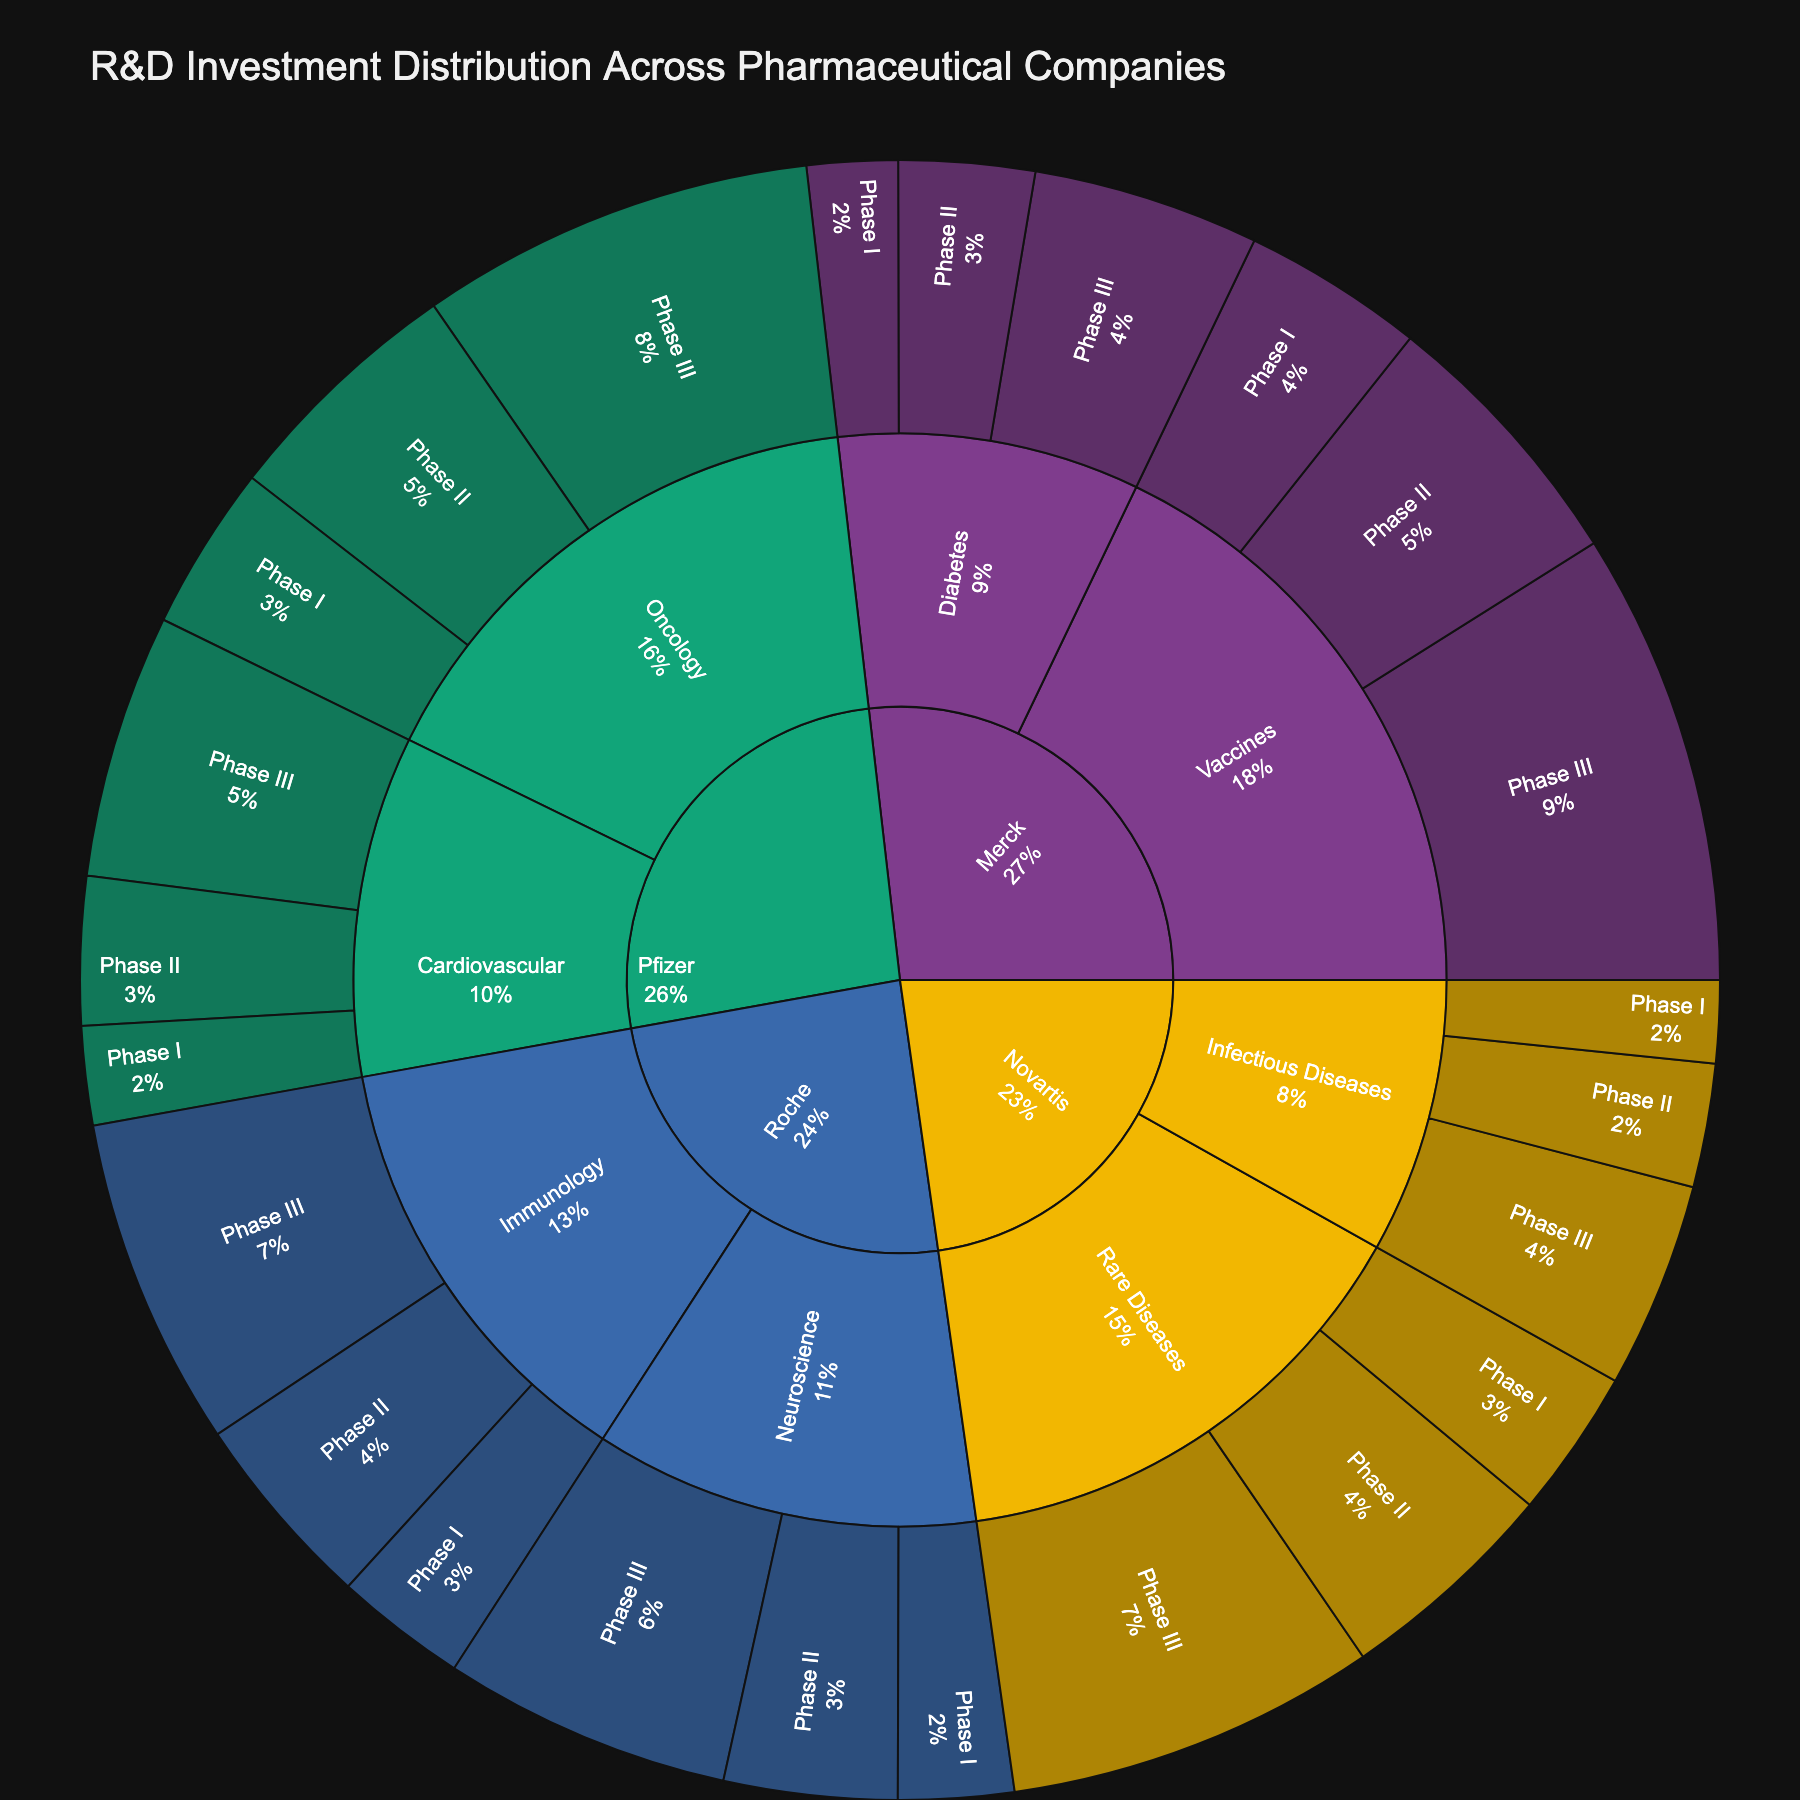what is the title of the figure? The title is usually displayed at the top of the plot. In this case, look for the text that is prominently displayed at the top of the visual.
Answer: R&D Investment Distribution Across Pharmaceutical Companies which company has the highest total investment in R&D? To determine the company with the highest total investment, sum up all the investments for each company and compare them. Pfizer has investments of 500+750+1200+300+450+800 totaling 4000 million, which is the highest in the dataset.
Answer: Pfizer what therapeutic area does Roche invest the most in? For Roche, sum the investments in both Immunology (400+600+1000) and Neuroscience (350+525+875) and compare. Roche invests 2000 million in Immunology.
Answer: Immunology which development phase receives the most investment from Novartis in Rare Diseases? Sum the investments for each development phase in Rare Diseases under Novartis (Phase I: 450, Phase II: 675, Phase III: 1125). Identify the phase with the highest sum. Phase III has 1125 million.
Answer: Phase III what is the total investment in Phase I development across all companies? Sum up all investments in Phase I across all companies (500+300+400+350+450+250+550+275). The total is 3075 million.
Answer: 3075 million how does the investment in Phase III development for Oncology compare to Cardiovascular for Pfizer? Compare the investments for Phase III in Oncology (1200) and Cardiovascular (800) for Pfizer. 1200 is greater than 800.
Answer: Oncology has greater investment than Cardiovascular which company has the smallest investment in Phase I? Compare the Phase I investments for each company. Novartis has the smallest at 250 million in Infectious Diseases.
Answer: Novartis what percentage of Merck's total investment is allocated to Vaccines in Phase III? Calculate Merck's total investment (550+825+1375+275+412+687 = 4124). Calculate the percentage of Phase III Vaccines (1375/4124 x 100).
Answer: 33.34% how does Roche's total investment in Neuroscience compare to Novartis' total in Infectious Diseases? Compare the sums for Neuroscience (350+525+875 = 1750) and Infectious Diseases (250+375+625 = 1250). 1750 is greater than 1250.
Answer: greater which therapeutic area under Pfizer has the lowest investment in Phase II development? Compare Phase II investments in Oncology (750) and Cardiovascular (450). Cardiovascular has the lower investment.
Answer: Cardiovascular 